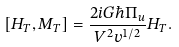Convert formula to latex. <formula><loc_0><loc_0><loc_500><loc_500>[ H _ { T } , M _ { T } ] = \frac { 2 i G \hbar { \Pi } _ { u } } { V ^ { 2 } v ^ { 1 / 2 } } H _ { T } .</formula> 